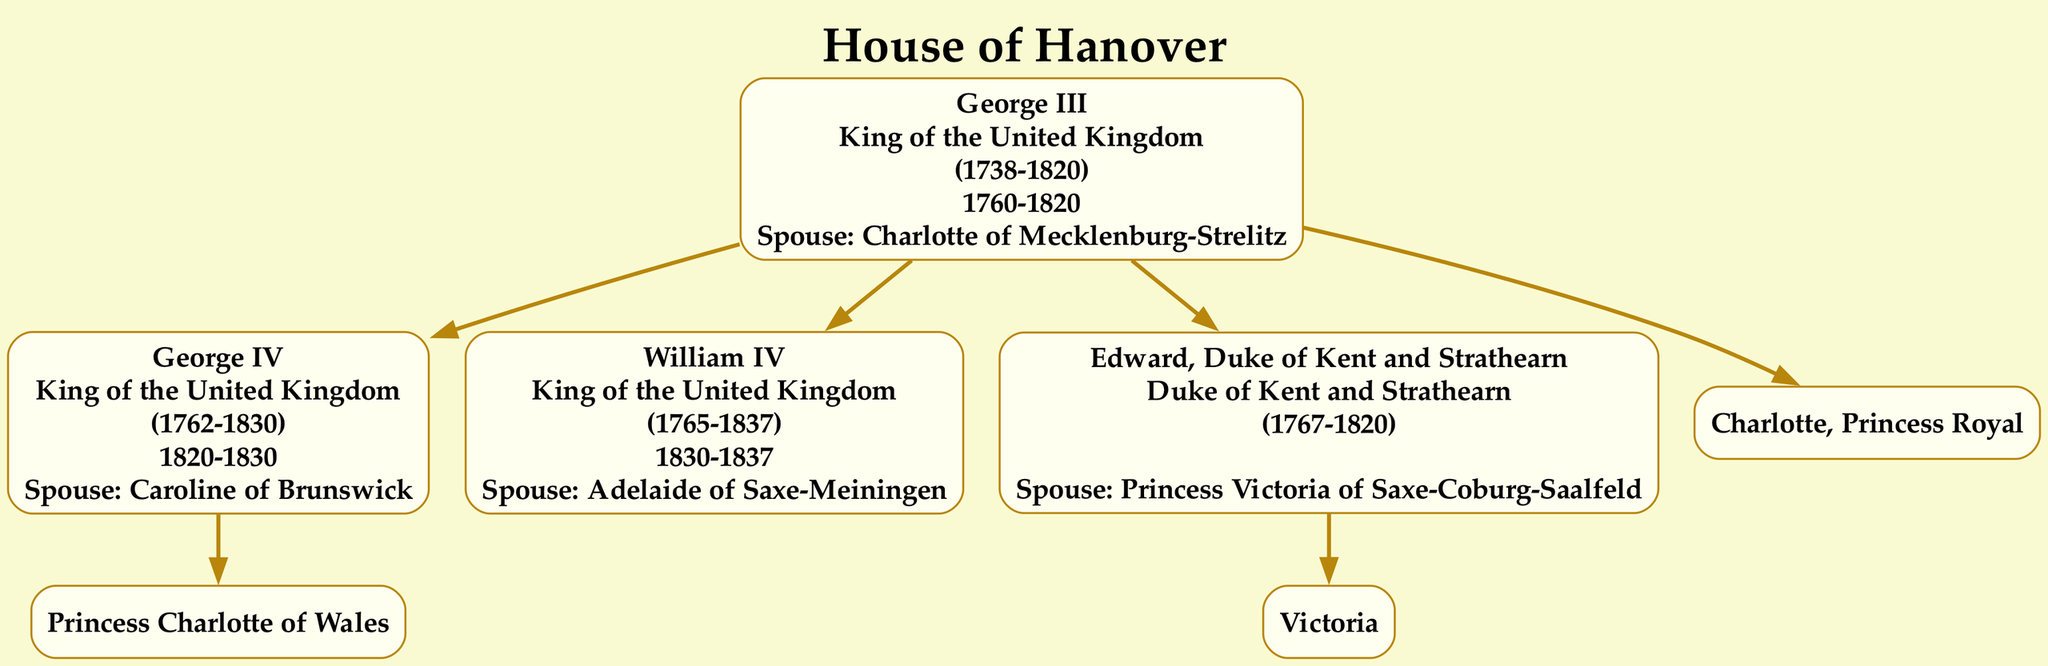What is the name of the current Queen in the family tree? To find the current Queen, locate the member titled "Queen of the United Kingdom" in the diagram. This title corresponds to "Victoria," who is listed as the child of "Edward, Duke of Kent and Strathearn."
Answer: Victoria Who was the spouse of George IV? To find George IV in the diagram, note the name under his title "King of the United Kingdom." His spouse is mentioned directly beneath his details. The spouse listed is "Caroline of Brunswick."
Answer: Caroline of Brunswick How many children did William IV have? William IV is noted to have no children listed underneath his details in the diagram. By observing the children section, it's clear that there are zero entries there.
Answer: 0 Which royal family house did Queen Victoria belong to? To determine Queen Victoria's royal house, look at any of the nodes which include her information. The house is specified at the top of the family tree as "House of Hanover."
Answer: House of Hanover What were the birth and death years of Edward VII? Edward VII is listed in the children of Queen Victoria. The diagram mentions that he was born in 1841 and died in 1910, which can be seen directly next to his name.
Answer: 1841-1910 Who is the eldest child of George III? George III has four children listed in his entry. The first child mentioned is "George IV," making him the eldest.
Answer: George IV Which title did Victoria hold? Victoria is indicated as "Queen of the United Kingdom" in her node in the family tree. This title is directly listed alongside her name.
Answer: Queen of the United Kingdom How many siblings did Victoria have? Upon examining the listed children of Edward, Duke of Kent and Strathearn (Victoria's father), there are a total of 9 children, including Victoria herself. Therefore, we subtract 1 from this total to find the number of siblings. That gives us 8 siblings.
Answer: 8 What was the reign period of William IV? William IV is listed in his node with a reign period specified as "1830-1837" in the diagram. This information flows from the title section related to his details.
Answer: 1830-1837 